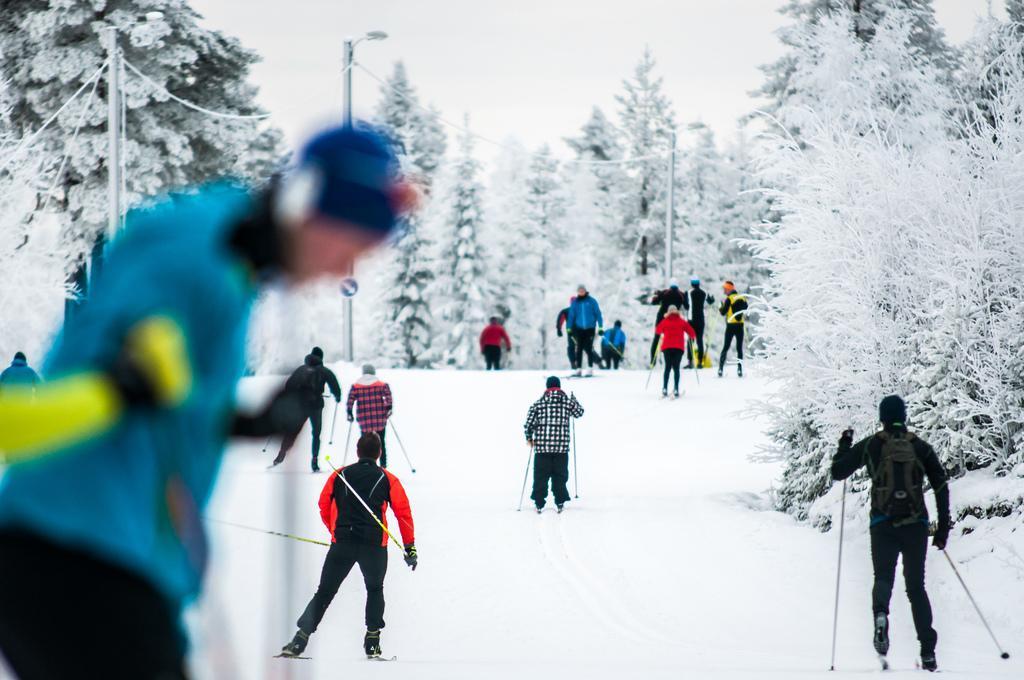Describe this image in one or two sentences. There is a group of people skating on a snow ground as we can see at the bottom of this image. We can see trees and poles in the background and the sky is at the top of this image. 